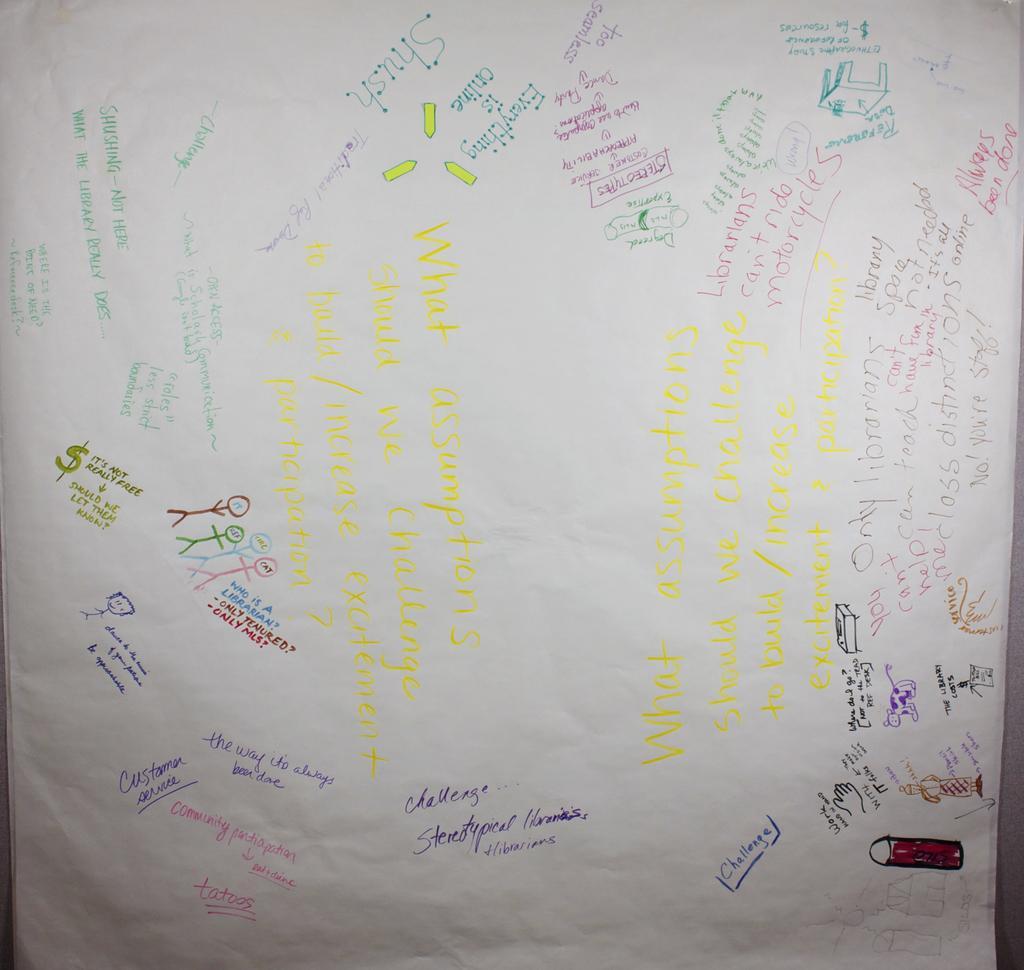Describe this image in one or two sentences. Here I can see a white color sheet on which I can see some text in multiple colors. 